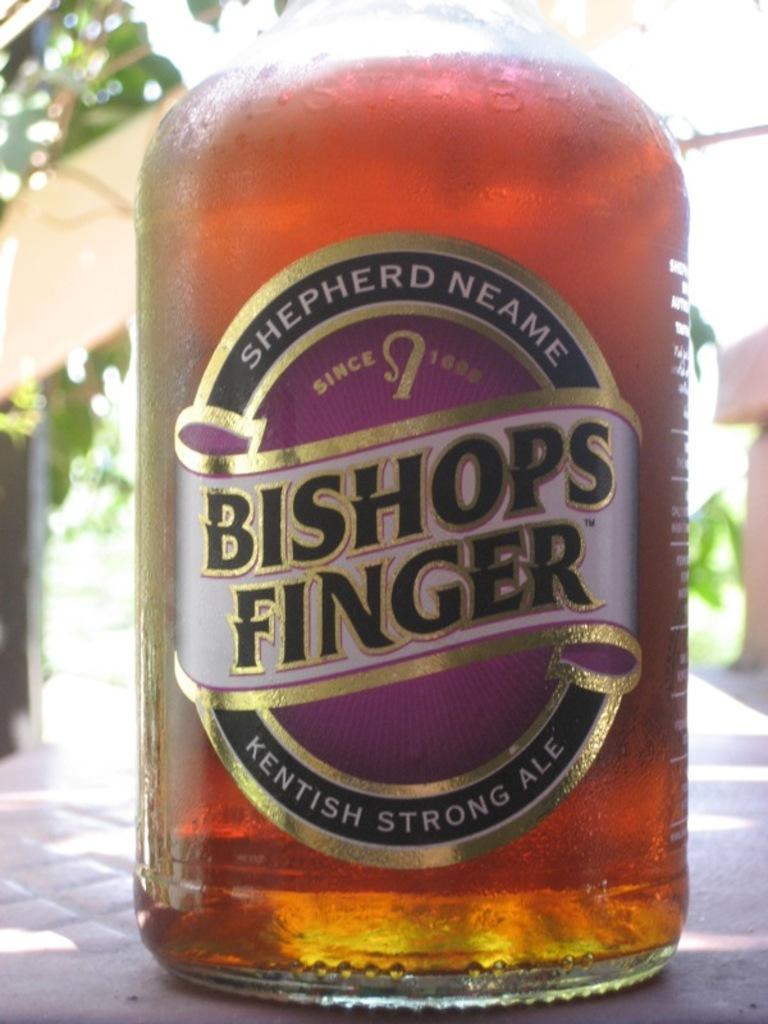What kind if beer is this?
Your answer should be very brief. Bishops finger. When was the company started?
Keep it short and to the point. 1698. 